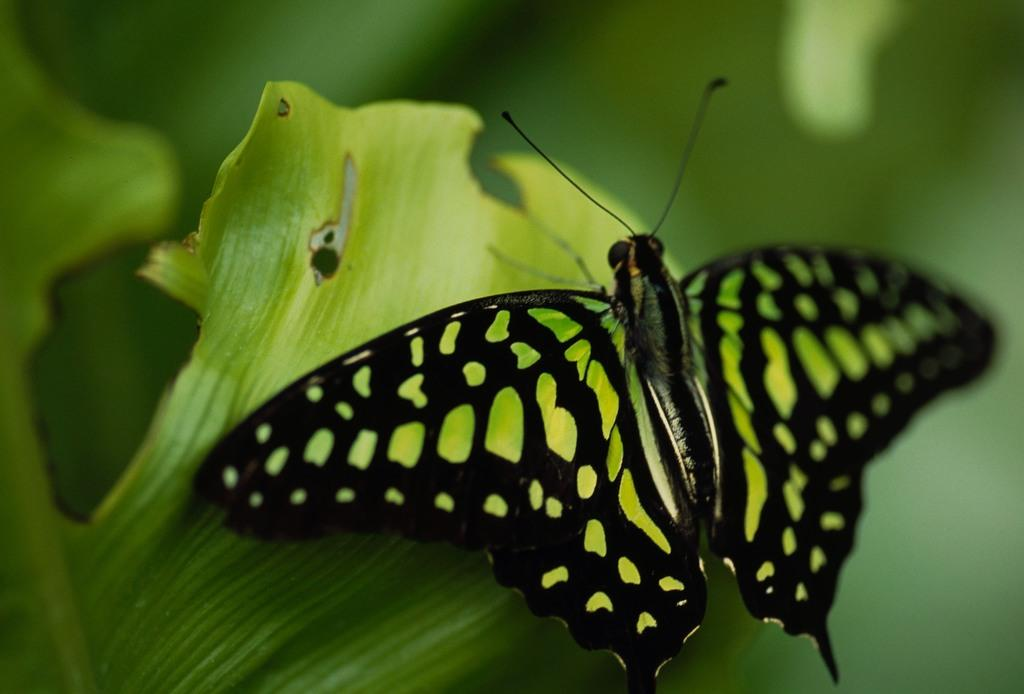What is the main subject of the image? There is a butterfly in the image. Where is the butterfly located? The butterfly is on a leaf. Can you describe the background of the image? The background of the image is blurry. What type of plate is visible in the image? There is no plate present in the image. 